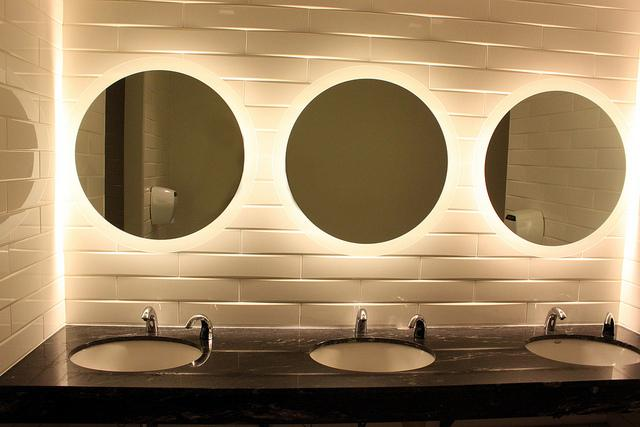How many sinks are on the row at this public bathroom area? three 